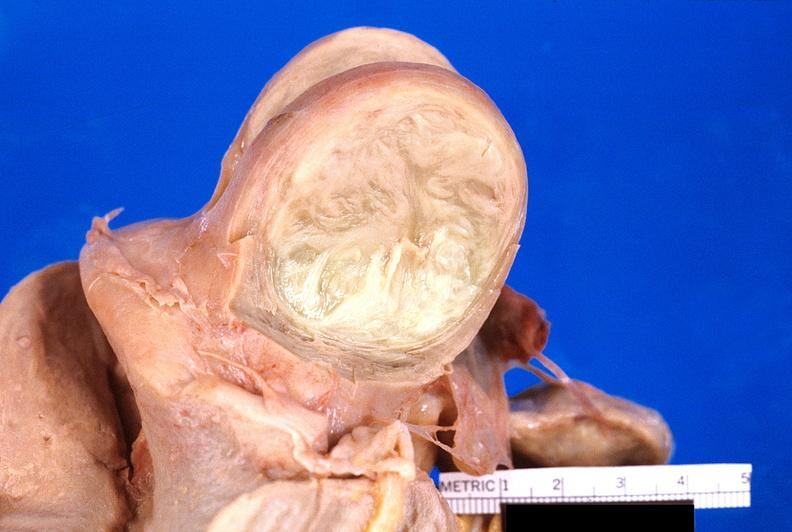does abdomen show uterus, leiomyoma?
Answer the question using a single word or phrase. No 